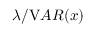Convert formula to latex. <formula><loc_0><loc_0><loc_500><loc_500>\lambda / { V A R } ( x )</formula> 